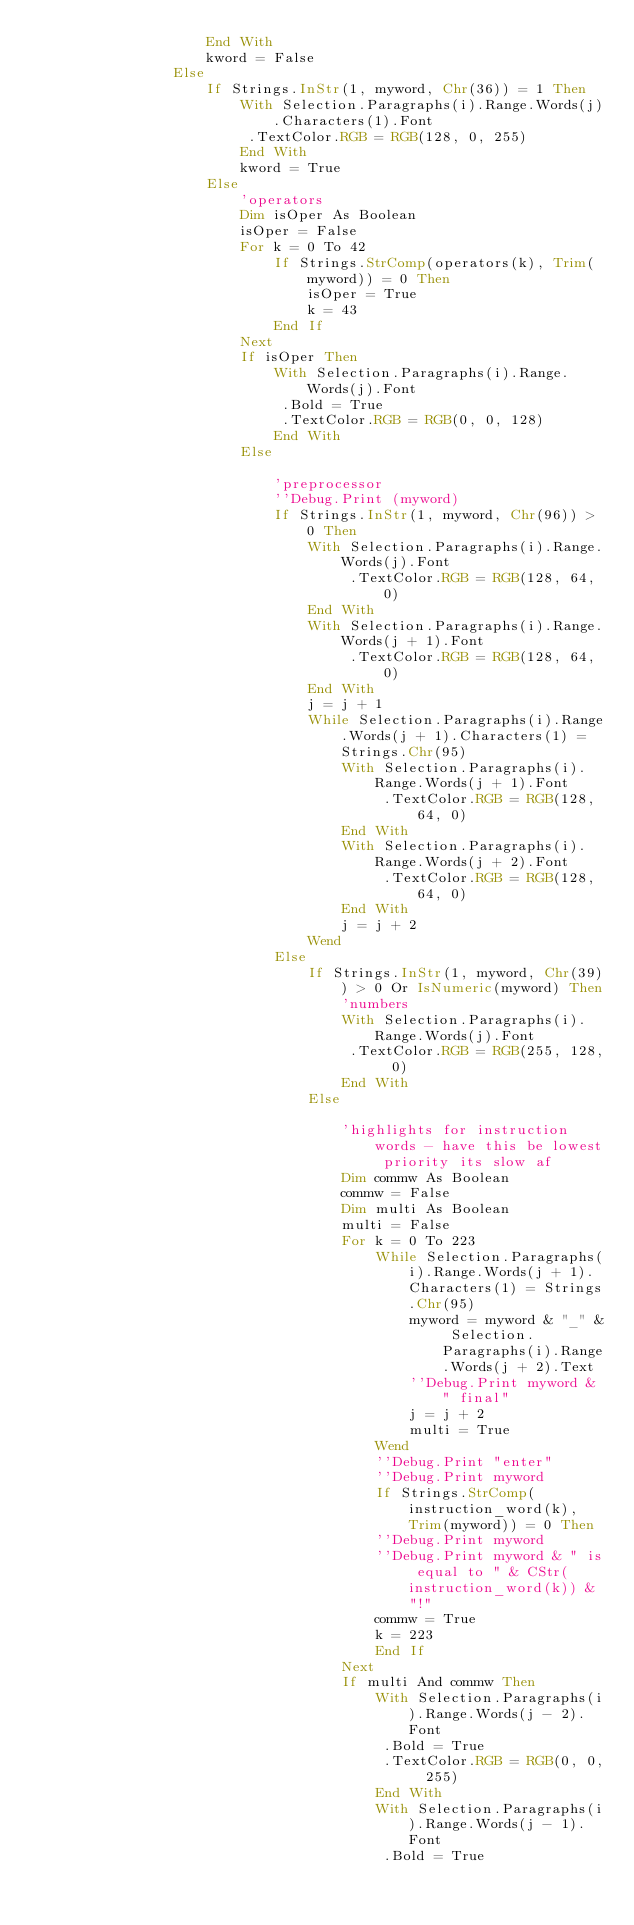<code> <loc_0><loc_0><loc_500><loc_500><_VisualBasic_>                    End With
                    kword = False
                Else
                    If Strings.InStr(1, myword, Chr(36)) = 1 Then
                        With Selection.Paragraphs(i).Range.Words(j).Characters(1).Font
                         .TextColor.RGB = RGB(128, 0, 255)
                        End With
                        kword = True
                    Else
                        'operators
                        Dim isOper As Boolean
                        isOper = False
                        For k = 0 To 42
                            If Strings.StrComp(operators(k), Trim(myword)) = 0 Then
                                isOper = True
                                k = 43
                            End If
                        Next
                        If isOper Then
                            With Selection.Paragraphs(i).Range.Words(j).Font
                             .Bold = True
                             .TextColor.RGB = RGB(0, 0, 128)
                            End With
                        Else
                        
                            'preprocessor
                            ''Debug.Print (myword)
                            If Strings.InStr(1, myword, Chr(96)) > 0 Then
                                With Selection.Paragraphs(i).Range.Words(j).Font
                                     .TextColor.RGB = RGB(128, 64, 0)
                                End With
                                With Selection.Paragraphs(i).Range.Words(j + 1).Font
                                     .TextColor.RGB = RGB(128, 64, 0)
                                End With
                                j = j + 1
                                While Selection.Paragraphs(i).Range.Words(j + 1).Characters(1) = Strings.Chr(95)
                                    With Selection.Paragraphs(i).Range.Words(j + 1).Font
                                         .TextColor.RGB = RGB(128, 64, 0)
                                    End With
                                    With Selection.Paragraphs(i).Range.Words(j + 2).Font
                                         .TextColor.RGB = RGB(128, 64, 0)
                                    End With
                                    j = j + 2
                                Wend
                            Else
                                If Strings.InStr(1, myword, Chr(39)) > 0 Or IsNumeric(myword) Then
                                    'numbers
                                    With Selection.Paragraphs(i).Range.Words(j).Font
                                     .TextColor.RGB = RGB(255, 128, 0)
                                    End With
                                Else
                                
                                    'highlights for instruction words - have this be lowest priority its slow af
                                    Dim commw As Boolean
                                    commw = False
                                    Dim multi As Boolean
                                    multi = False
                                    For k = 0 To 223
                                        While Selection.Paragraphs(i).Range.Words(j + 1).Characters(1) = Strings.Chr(95)
                                            myword = myword & "_" & Selection.Paragraphs(i).Range.Words(j + 2).Text
                                            ''Debug.Print myword & " final"
                                            j = j + 2
                                            multi = True
                                        Wend
                                        ''Debug.Print "enter"
                                        ''Debug.Print myword
                                        If Strings.StrComp(instruction_word(k), Trim(myword)) = 0 Then
                                        ''Debug.Print myword
                                        ''Debug.Print myword & " is equal to " & CStr(instruction_word(k)) & "!"
                                        commw = True
                                        k = 223
                                        End If
                                    Next
                                    If multi And commw Then
                                        With Selection.Paragraphs(i).Range.Words(j - 2).Font
                                         .Bold = True
                                         .TextColor.RGB = RGB(0, 0, 255)
                                        End With
                                        With Selection.Paragraphs(i).Range.Words(j - 1).Font
                                         .Bold = True</code> 